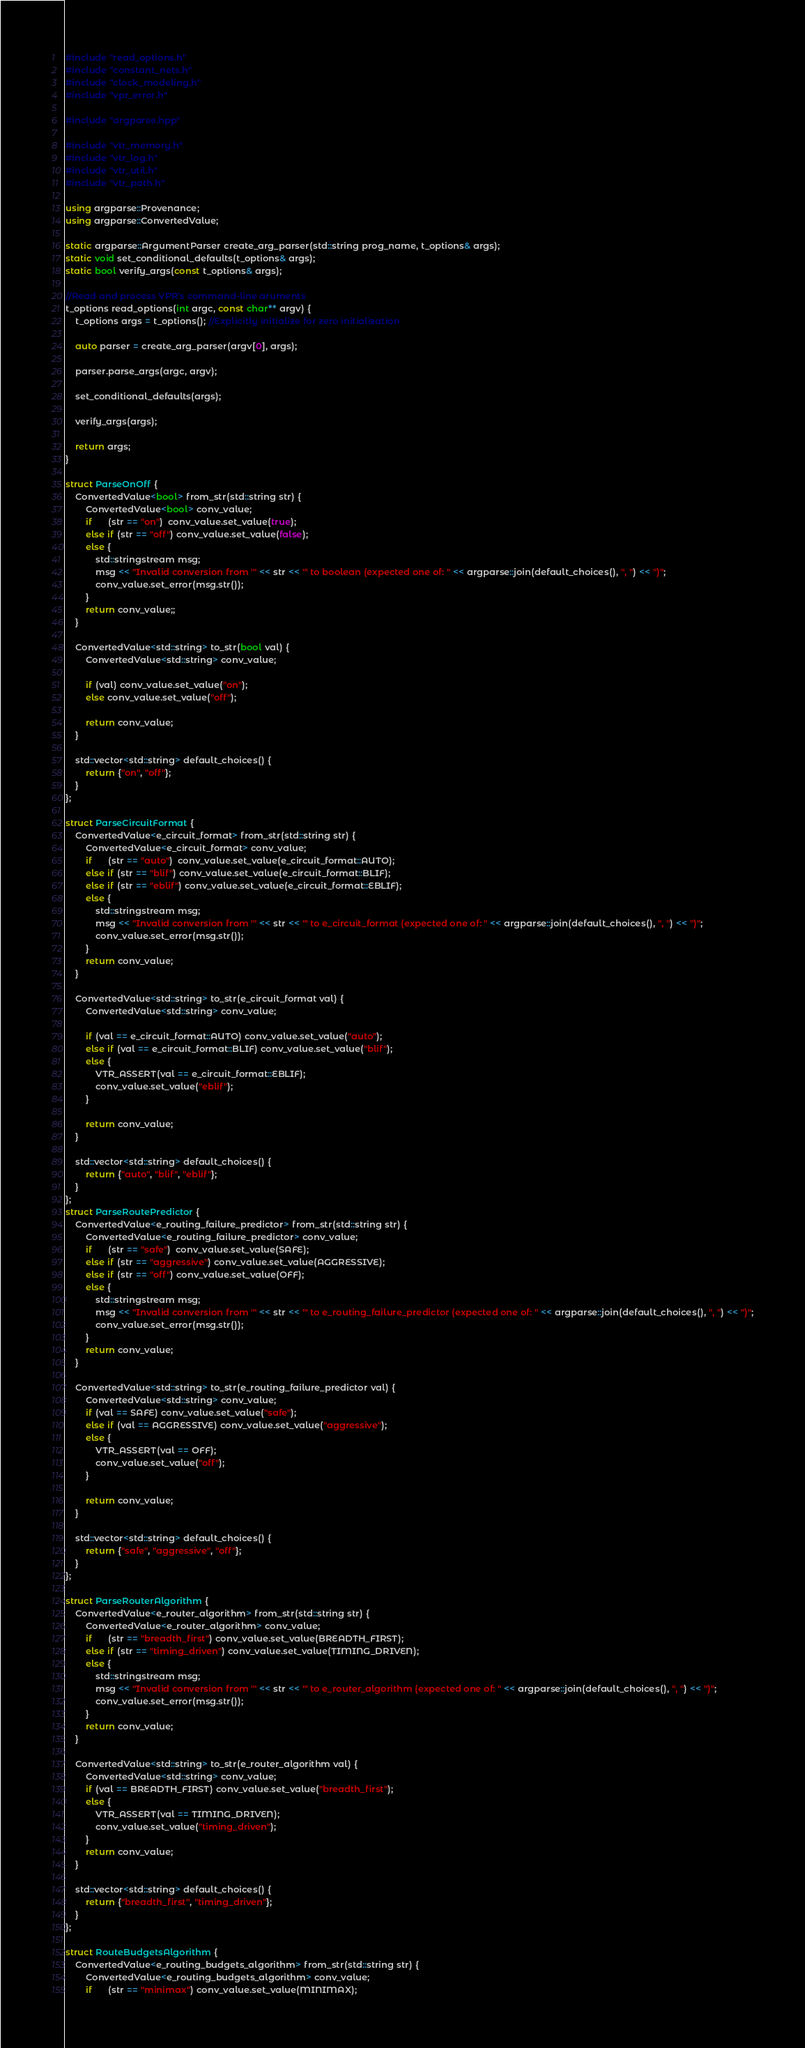Convert code to text. <code><loc_0><loc_0><loc_500><loc_500><_C++_>#include "read_options.h"
#include "constant_nets.h"
#include "clock_modeling.h"
#include "vpr_error.h"

#include "argparse.hpp"

#include "vtr_memory.h"
#include "vtr_log.h"
#include "vtr_util.h"
#include "vtr_path.h"

using argparse::Provenance;
using argparse::ConvertedValue;

static argparse::ArgumentParser create_arg_parser(std::string prog_name, t_options& args);
static void set_conditional_defaults(t_options& args);
static bool verify_args(const t_options& args);

//Read and process VPR's command-line aruments
t_options read_options(int argc, const char** argv) {
    t_options args = t_options(); //Explicitly initialize for zero initialization

    auto parser = create_arg_parser(argv[0], args);

    parser.parse_args(argc, argv);

    set_conditional_defaults(args);

    verify_args(args);

    return args;
}

struct ParseOnOff {
    ConvertedValue<bool> from_str(std::string str) {
        ConvertedValue<bool> conv_value;
        if      (str == "on")  conv_value.set_value(true);
        else if (str == "off") conv_value.set_value(false);
        else {
            std::stringstream msg;
            msg << "Invalid conversion from '" << str << "' to boolean (expected one of: " << argparse::join(default_choices(), ", ") << ")";
            conv_value.set_error(msg.str());
        }
        return conv_value;;
    }

    ConvertedValue<std::string> to_str(bool val) {
        ConvertedValue<std::string> conv_value;

        if (val) conv_value.set_value("on");
        else conv_value.set_value("off");

        return conv_value;
    }

    std::vector<std::string> default_choices() {
        return {"on", "off"};
    }
};

struct ParseCircuitFormat {
    ConvertedValue<e_circuit_format> from_str(std::string str) {
        ConvertedValue<e_circuit_format> conv_value;
        if      (str == "auto")  conv_value.set_value(e_circuit_format::AUTO);
        else if (str == "blif") conv_value.set_value(e_circuit_format::BLIF);
        else if (str == "eblif") conv_value.set_value(e_circuit_format::EBLIF);
        else {
            std::stringstream msg;
            msg << "Invalid conversion from '" << str << "' to e_circuit_format (expected one of: " << argparse::join(default_choices(), ", ") << ")";
            conv_value.set_error(msg.str());
        }
        return conv_value;
    }

    ConvertedValue<std::string> to_str(e_circuit_format val) {
        ConvertedValue<std::string> conv_value;

        if (val == e_circuit_format::AUTO) conv_value.set_value("auto");
        else if (val == e_circuit_format::BLIF) conv_value.set_value("blif");
        else {
            VTR_ASSERT(val == e_circuit_format::EBLIF);
            conv_value.set_value("eblif");
        }

        return conv_value;
    }

    std::vector<std::string> default_choices() {
        return {"auto", "blif", "eblif"};
    }
};
struct ParseRoutePredictor {
    ConvertedValue<e_routing_failure_predictor> from_str(std::string str) {
        ConvertedValue<e_routing_failure_predictor> conv_value;
        if      (str == "safe")  conv_value.set_value(SAFE);
        else if (str == "aggressive") conv_value.set_value(AGGRESSIVE);
        else if (str == "off") conv_value.set_value(OFF);
        else {
            std::stringstream msg;
            msg << "Invalid conversion from '" << str << "' to e_routing_failure_predictor (expected one of: " << argparse::join(default_choices(), ", ") << ")";
            conv_value.set_error(msg.str());
        }
        return conv_value;
    }

    ConvertedValue<std::string> to_str(e_routing_failure_predictor val) {
        ConvertedValue<std::string> conv_value;
        if (val == SAFE) conv_value.set_value("safe");
        else if (val == AGGRESSIVE) conv_value.set_value("aggressive");
        else {
            VTR_ASSERT(val == OFF);
            conv_value.set_value("off");
        }

        return conv_value;
    }

    std::vector<std::string> default_choices() {
        return {"safe", "aggressive", "off"};
    }
};

struct ParseRouterAlgorithm {
    ConvertedValue<e_router_algorithm> from_str(std::string str) {
        ConvertedValue<e_router_algorithm> conv_value;
        if      (str == "breadth_first") conv_value.set_value(BREADTH_FIRST);
        else if (str == "timing_driven") conv_value.set_value(TIMING_DRIVEN);
        else {
            std::stringstream msg;
            msg << "Invalid conversion from '" << str << "' to e_router_algorithm (expected one of: " << argparse::join(default_choices(), ", ") << ")";
            conv_value.set_error(msg.str());
        }
        return conv_value;
    }

    ConvertedValue<std::string> to_str(e_router_algorithm val) {
        ConvertedValue<std::string> conv_value;
        if (val == BREADTH_FIRST) conv_value.set_value("breadth_first");
        else {
            VTR_ASSERT(val == TIMING_DRIVEN);
            conv_value.set_value("timing_driven");
        }
        return conv_value;
    }

    std::vector<std::string> default_choices() {
        return {"breadth_first", "timing_driven"};
    }
};

struct RouteBudgetsAlgorithm {
    ConvertedValue<e_routing_budgets_algorithm> from_str(std::string str) {
        ConvertedValue<e_routing_budgets_algorithm> conv_value;
        if      (str == "minimax") conv_value.set_value(MINIMAX);</code> 